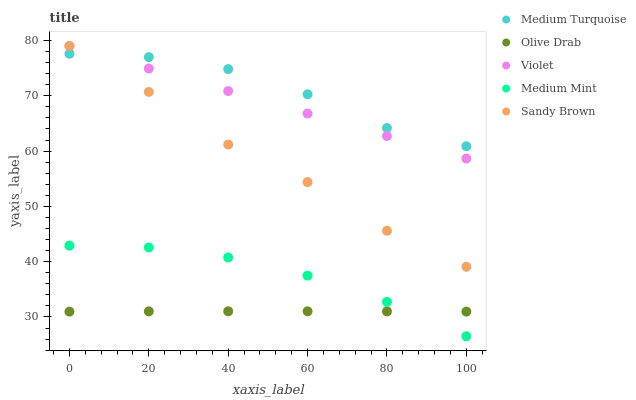Does Olive Drab have the minimum area under the curve?
Answer yes or no. Yes. Does Medium Turquoise have the maximum area under the curve?
Answer yes or no. Yes. Does Sandy Brown have the minimum area under the curve?
Answer yes or no. No. Does Sandy Brown have the maximum area under the curve?
Answer yes or no. No. Is Violet the smoothest?
Answer yes or no. Yes. Is Medium Turquoise the roughest?
Answer yes or no. Yes. Is Sandy Brown the smoothest?
Answer yes or no. No. Is Sandy Brown the roughest?
Answer yes or no. No. Does Medium Mint have the lowest value?
Answer yes or no. Yes. Does Sandy Brown have the lowest value?
Answer yes or no. No. Does Violet have the highest value?
Answer yes or no. Yes. Does Olive Drab have the highest value?
Answer yes or no. No. Is Medium Mint less than Sandy Brown?
Answer yes or no. Yes. Is Violet greater than Medium Mint?
Answer yes or no. Yes. Does Sandy Brown intersect Medium Turquoise?
Answer yes or no. Yes. Is Sandy Brown less than Medium Turquoise?
Answer yes or no. No. Is Sandy Brown greater than Medium Turquoise?
Answer yes or no. No. Does Medium Mint intersect Sandy Brown?
Answer yes or no. No. 